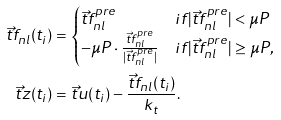Convert formula to latex. <formula><loc_0><loc_0><loc_500><loc_500>\vec { t } { f } _ { n l } ( t _ { i } ) & = \begin{cases} \vec { t } { f } _ { n l } ^ { p r e } & i f | \vec { t } { f } _ { n l } ^ { p r e } | < \mu P \\ - \mu P \cdot \frac { \vec { t } { f } _ { n l } ^ { p r e } } { | \vec { t } { f } _ { n l } ^ { p r e } | } & i f | \vec { t } { f } _ { n l } ^ { p r e } | \geq \mu P , \end{cases} \\ \vec { t } { z } ( t _ { i } ) & = \vec { t } { u } ( t _ { i } ) - \frac { \vec { t } { f } _ { n l } ( t _ { i } ) } { k _ { t } } .</formula> 